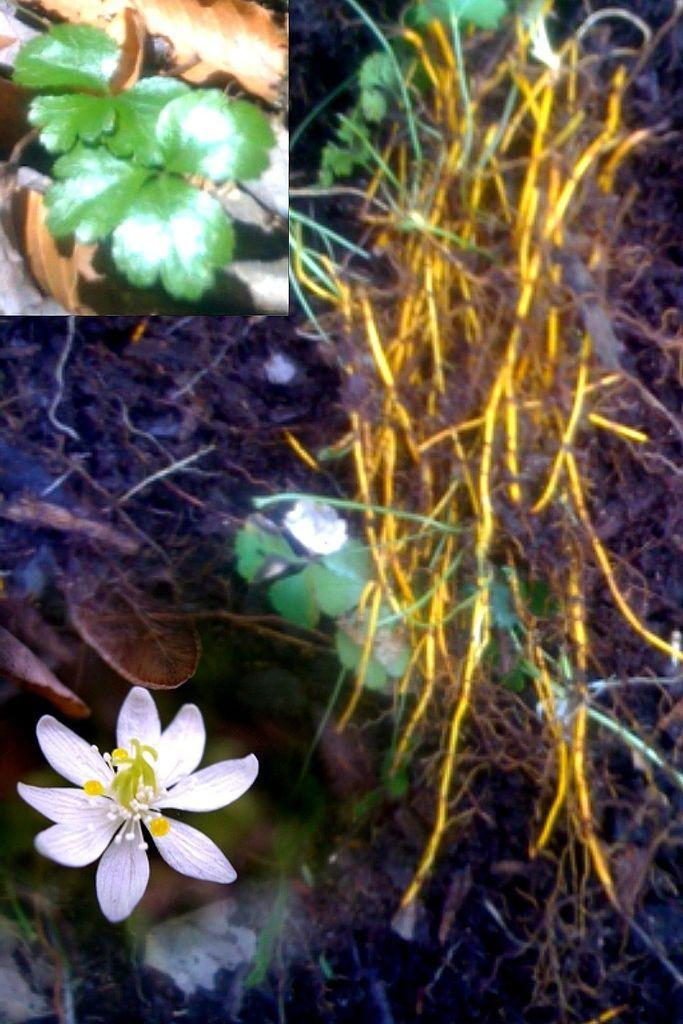What is the flower placed in, as seen in the image? The flower is in the water. What other plant can be seen in the image? There is a small plant in the image. What type of vegetation is visible in the image? Grass is visible in the image. What type of can is floating in the water next to the flower? There is no can present in the image; the flower is simply placed in the water. 